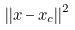<formula> <loc_0><loc_0><loc_500><loc_500>| | x - x _ { c } | | ^ { 2 }</formula> 